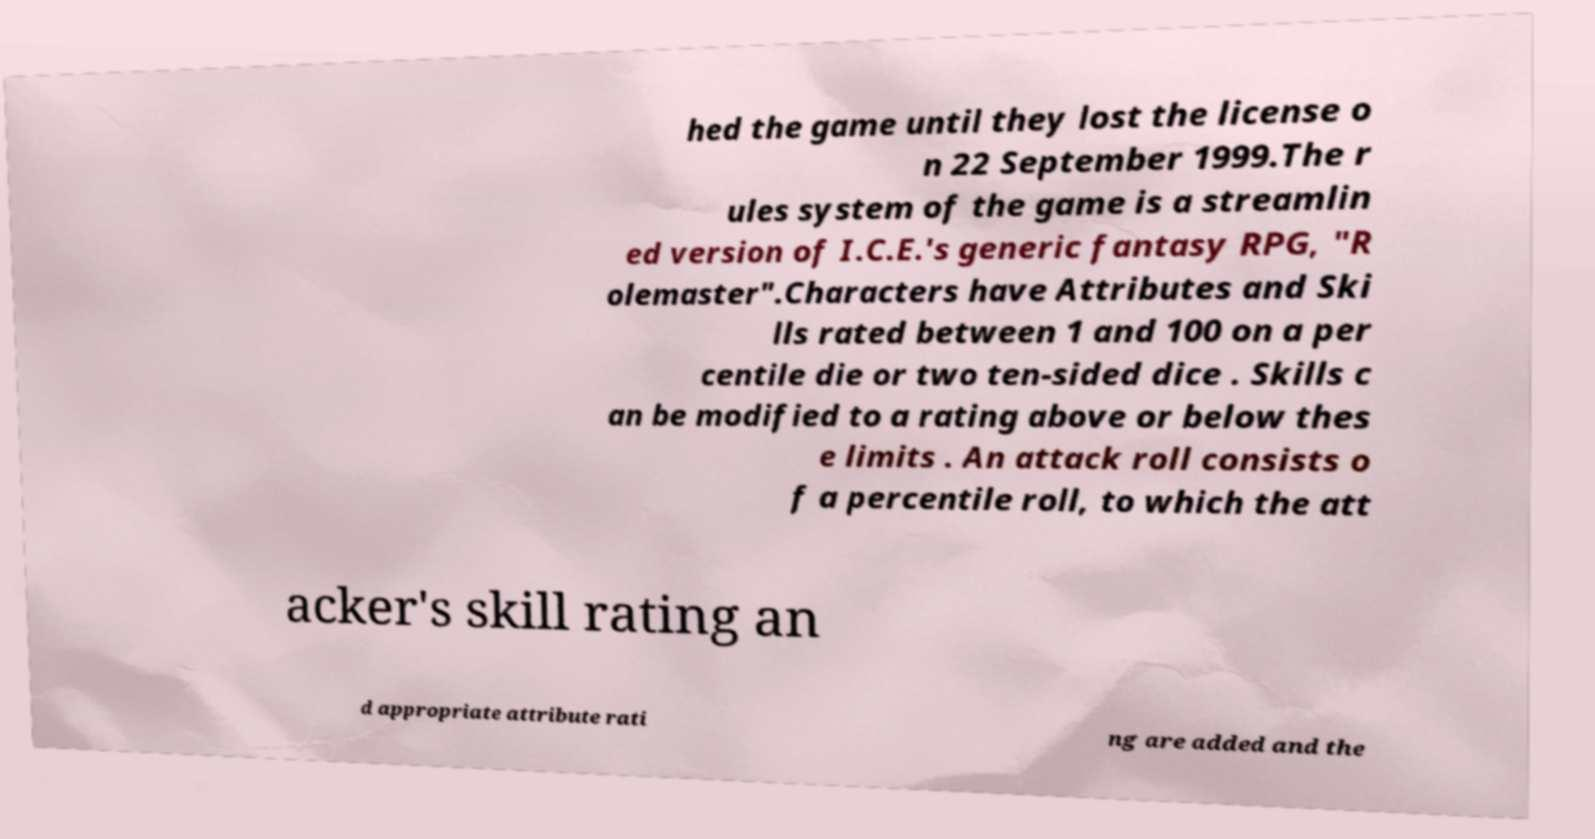Can you accurately transcribe the text from the provided image for me? hed the game until they lost the license o n 22 September 1999.The r ules system of the game is a streamlin ed version of I.C.E.'s generic fantasy RPG, "R olemaster".Characters have Attributes and Ski lls rated between 1 and 100 on a per centile die or two ten-sided dice . Skills c an be modified to a rating above or below thes e limits . An attack roll consists o f a percentile roll, to which the att acker's skill rating an d appropriate attribute rati ng are added and the 